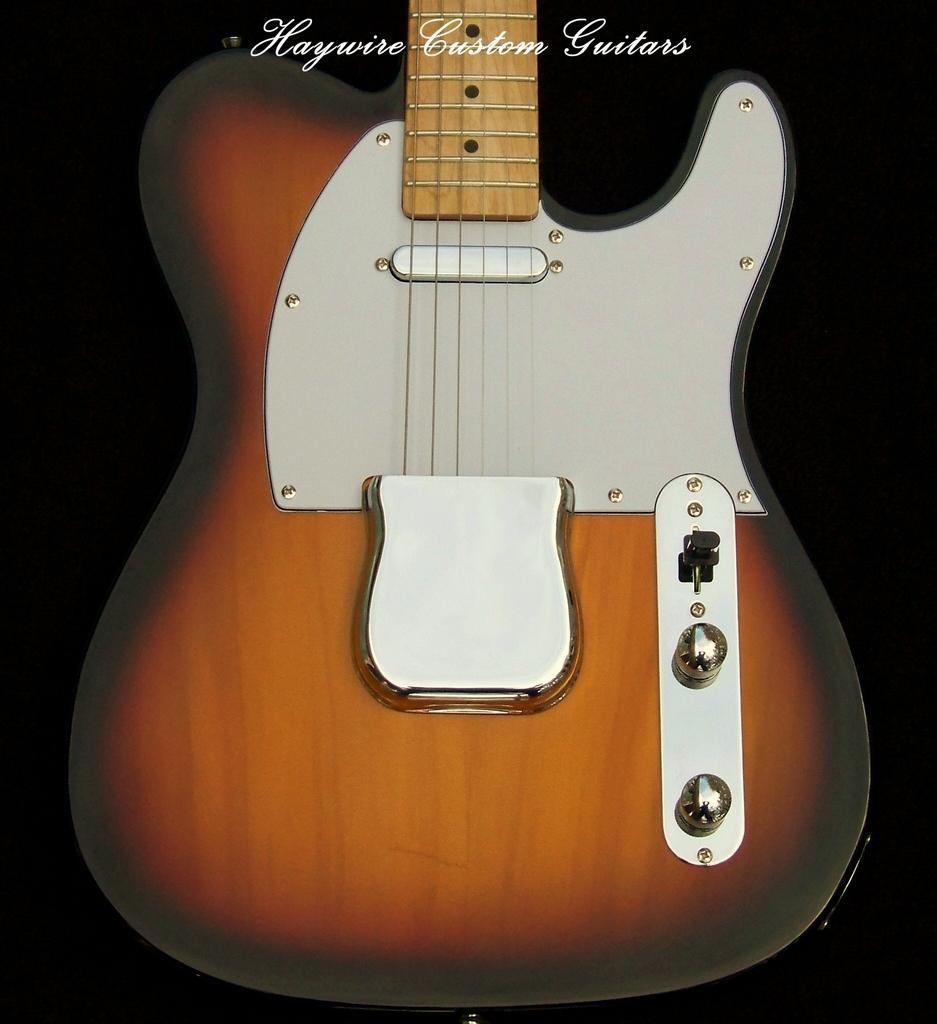Please provide a concise description of this image. In this image i can see a red color guitar. 